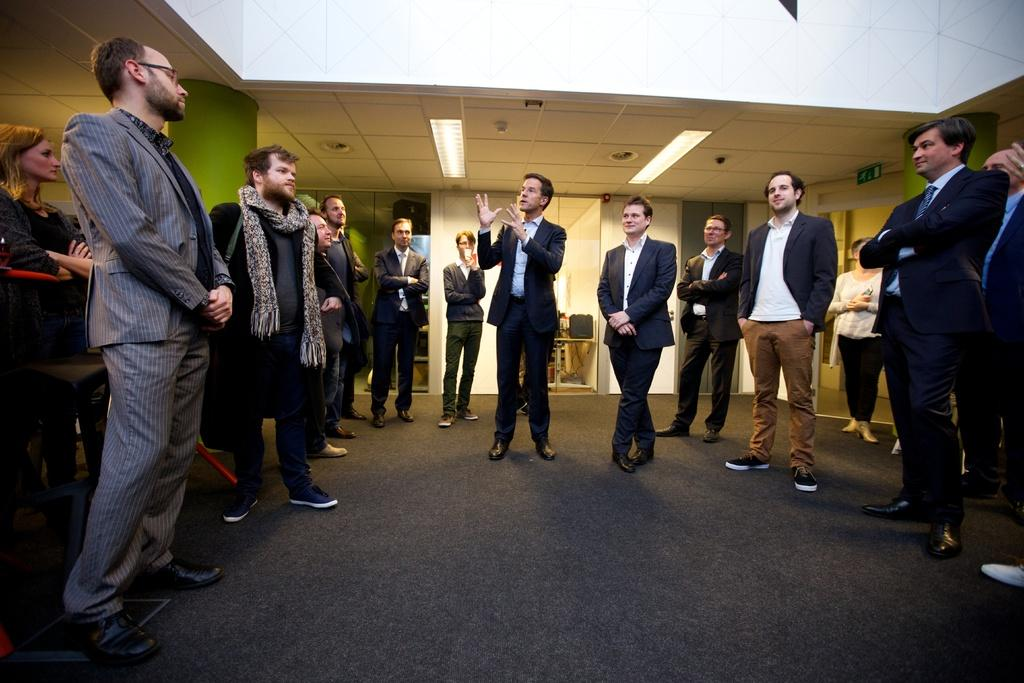What is the main subject of the image? The main subject of the image is a group of people standing. What can be seen in the image besides the people? There are lights and pillars visible in the image. What is in the background of the image? There is a wall in the background of the image. Where is the desk located in the image? There is no desk present in the image. What type of sponge can be seen in the image? There is no sponge present in the image. 